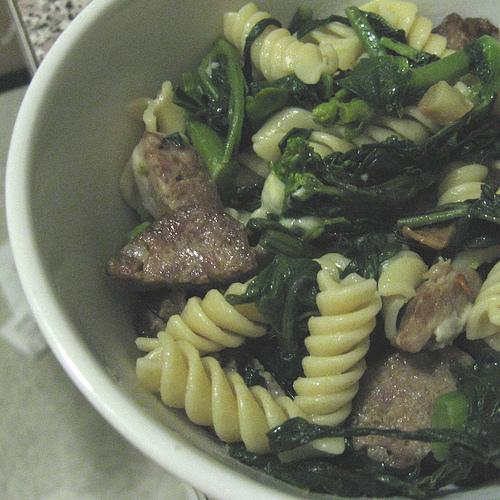Does this pasta dish include shrimp?
Quick response, please. No. Is the food in the bowl cold?
Be succinct. No. What is in the pasta?
Quick response, please. Meat and green vegetables. What vegetable is in the pasta?
Write a very short answer. Spinach. 